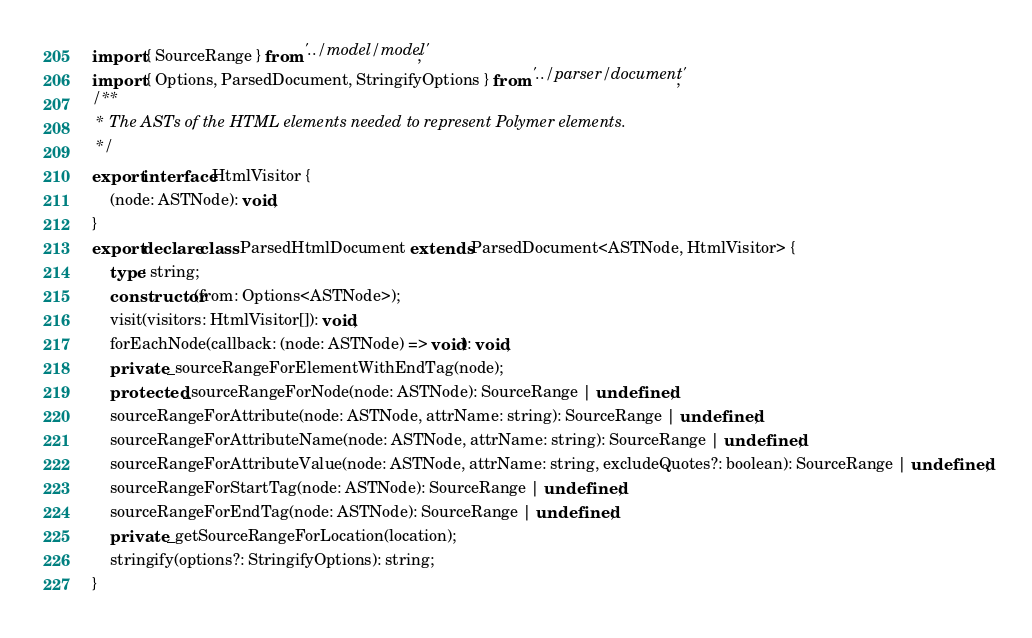Convert code to text. <code><loc_0><loc_0><loc_500><loc_500><_TypeScript_>import { SourceRange } from '../model/model';
import { Options, ParsedDocument, StringifyOptions } from '../parser/document';
/**
 * The ASTs of the HTML elements needed to represent Polymer elements.
 */
export interface HtmlVisitor {
    (node: ASTNode): void;
}
export declare class ParsedHtmlDocument extends ParsedDocument<ASTNode, HtmlVisitor> {
    type: string;
    constructor(from: Options<ASTNode>);
    visit(visitors: HtmlVisitor[]): void;
    forEachNode(callback: (node: ASTNode) => void): void;
    private _sourceRangeForElementWithEndTag(node);
    protected _sourceRangeForNode(node: ASTNode): SourceRange | undefined;
    sourceRangeForAttribute(node: ASTNode, attrName: string): SourceRange | undefined;
    sourceRangeForAttributeName(node: ASTNode, attrName: string): SourceRange | undefined;
    sourceRangeForAttributeValue(node: ASTNode, attrName: string, excludeQuotes?: boolean): SourceRange | undefined;
    sourceRangeForStartTag(node: ASTNode): SourceRange | undefined;
    sourceRangeForEndTag(node: ASTNode): SourceRange | undefined;
    private _getSourceRangeForLocation(location);
    stringify(options?: StringifyOptions): string;
}
</code> 